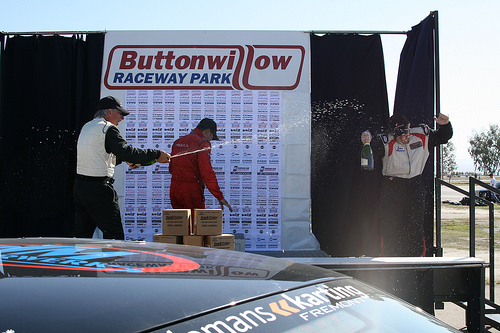<image>
Is there a champagne under the sign? No. The champagne is not positioned under the sign. The vertical relationship between these objects is different. Where is the man in relation to the sign? Is it next to the sign? No. The man is not positioned next to the sign. They are located in different areas of the scene. 